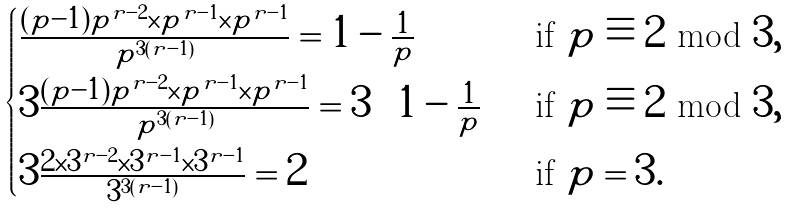Convert formula to latex. <formula><loc_0><loc_0><loc_500><loc_500>\begin{cases} \frac { ( p - 1 ) p ^ { r - 2 } \times p ^ { r - 1 } \times p ^ { r - 1 } } { p ^ { 3 ( r - 1 ) } } = 1 - \frac { 1 } { p } & \text {if $p\equiv 2$ mod $3$} , \\ 3 \frac { ( p - 1 ) p ^ { r - 2 } \times p ^ { r - 1 } \times p ^ { r - 1 } } { p ^ { 3 ( r - 1 ) } } = 3 \left ( 1 - \frac { 1 } { p } \right ) & \text {if $p\equiv 2$ mod $3$} , \\ 3 \frac { 2 \times 3 ^ { r - 2 } \times 3 ^ { r - 1 } \times 3 ^ { r - 1 } } { 3 ^ { 3 ( r - 1 ) } } = 2 & \text {if $p=3$} . \end{cases}</formula> 